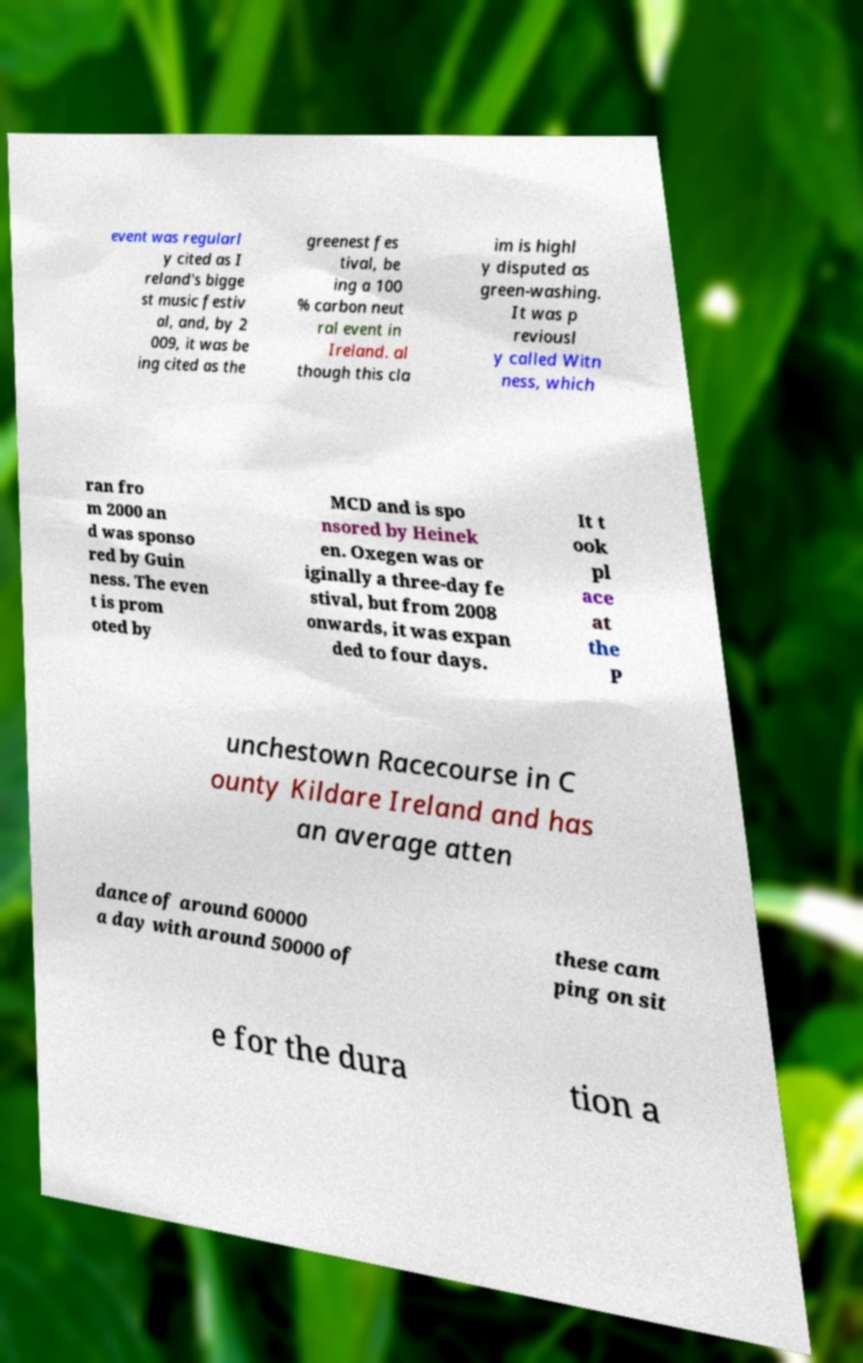What messages or text are displayed in this image? I need them in a readable, typed format. event was regularl y cited as I reland's bigge st music festiv al, and, by 2 009, it was be ing cited as the greenest fes tival, be ing a 100 % carbon neut ral event in Ireland. al though this cla im is highl y disputed as green-washing. It was p reviousl y called Witn ness, which ran fro m 2000 an d was sponso red by Guin ness. The even t is prom oted by MCD and is spo nsored by Heinek en. Oxegen was or iginally a three-day fe stival, but from 2008 onwards, it was expan ded to four days. It t ook pl ace at the P unchestown Racecourse in C ounty Kildare Ireland and has an average atten dance of around 60000 a day with around 50000 of these cam ping on sit e for the dura tion a 